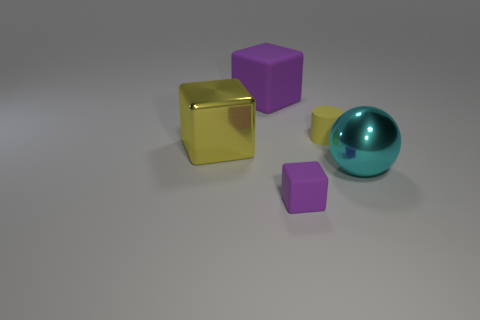Subtract all big blocks. How many blocks are left? 1 Add 4 yellow shiny blocks. How many objects exist? 9 Subtract all blocks. How many objects are left? 2 Add 3 tiny purple blocks. How many tiny purple blocks exist? 4 Subtract 0 purple balls. How many objects are left? 5 Subtract all large gray balls. Subtract all large yellow metallic objects. How many objects are left? 4 Add 3 small matte blocks. How many small matte blocks are left? 4 